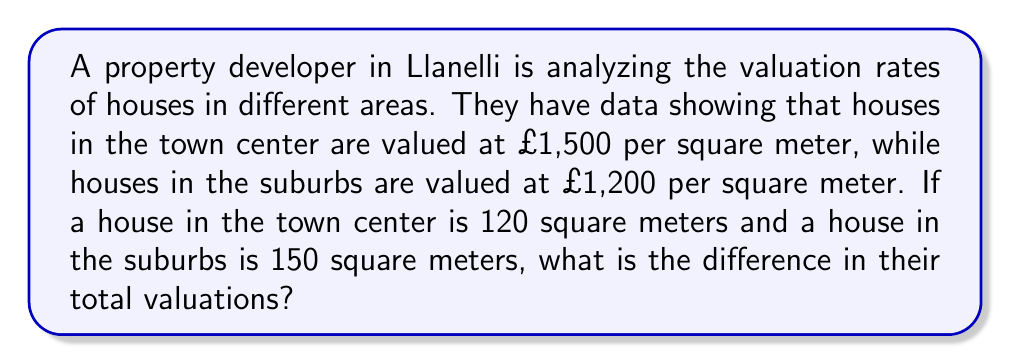Show me your answer to this math problem. Let's approach this step-by-step:

1. Calculate the valuation of the house in the town center:
   $$ \text{Town Center Valuation} = £1,500/m^2 \times 120m^2 = £180,000 $$

2. Calculate the valuation of the house in the suburbs:
   $$ \text{Suburbs Valuation} = £1,200/m^2 \times 150m^2 = £180,000 $$

3. Find the difference between the two valuations:
   $$ \text{Difference} = \text{Town Center Valuation} - \text{Suburbs Valuation} $$
   $$ \text{Difference} = £180,000 - £180,000 = £0 $$

Therefore, despite the difference in size and price per square meter, both properties have the same total valuation.
Answer: £0 